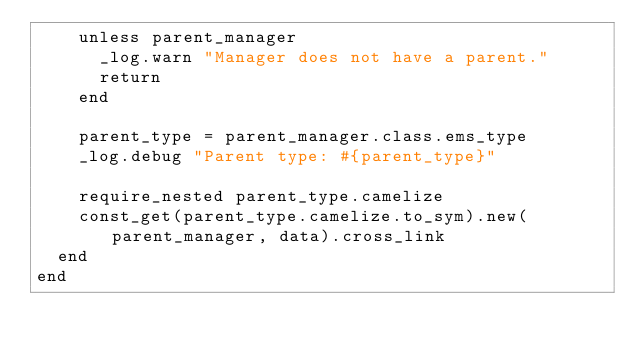<code> <loc_0><loc_0><loc_500><loc_500><_Ruby_>    unless parent_manager
      _log.warn "Manager does not have a parent."
      return
    end

    parent_type = parent_manager.class.ems_type
    _log.debug "Parent type: #{parent_type}"

    require_nested parent_type.camelize
    const_get(parent_type.camelize.to_sym).new(parent_manager, data).cross_link
  end
end
</code> 